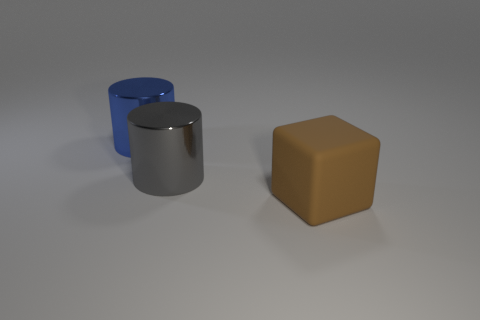Do the brown cube and the cylinder that is on the right side of the blue shiny cylinder have the same size?
Your response must be concise. Yes. How many objects are either things that are behind the large rubber cube or big things on the left side of the large cube?
Your response must be concise. 2. What color is the object that is on the right side of the big gray cylinder?
Make the answer very short. Brown. Is there a large thing right of the shiny thing that is in front of the blue cylinder?
Ensure brevity in your answer.  Yes. Are there fewer cyan matte blocks than big gray objects?
Your answer should be compact. Yes. What material is the object behind the cylinder that is in front of the blue metallic cylinder?
Make the answer very short. Metal. Is the gray metal cylinder the same size as the blue cylinder?
Provide a succinct answer. Yes. What number of things are gray metal cylinders or green rubber cubes?
Provide a succinct answer. 1. How big is the object that is both in front of the blue shiny thing and left of the brown rubber object?
Your answer should be compact. Large. Is the number of blue things that are in front of the rubber object less than the number of large red rubber objects?
Provide a succinct answer. No. 